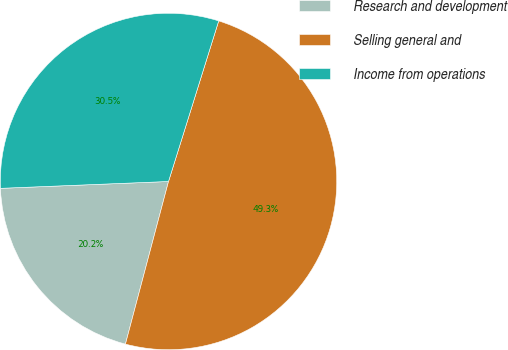Convert chart to OTSL. <chart><loc_0><loc_0><loc_500><loc_500><pie_chart><fcel>Research and development<fcel>Selling general and<fcel>Income from operations<nl><fcel>20.23%<fcel>49.3%<fcel>30.47%<nl></chart> 